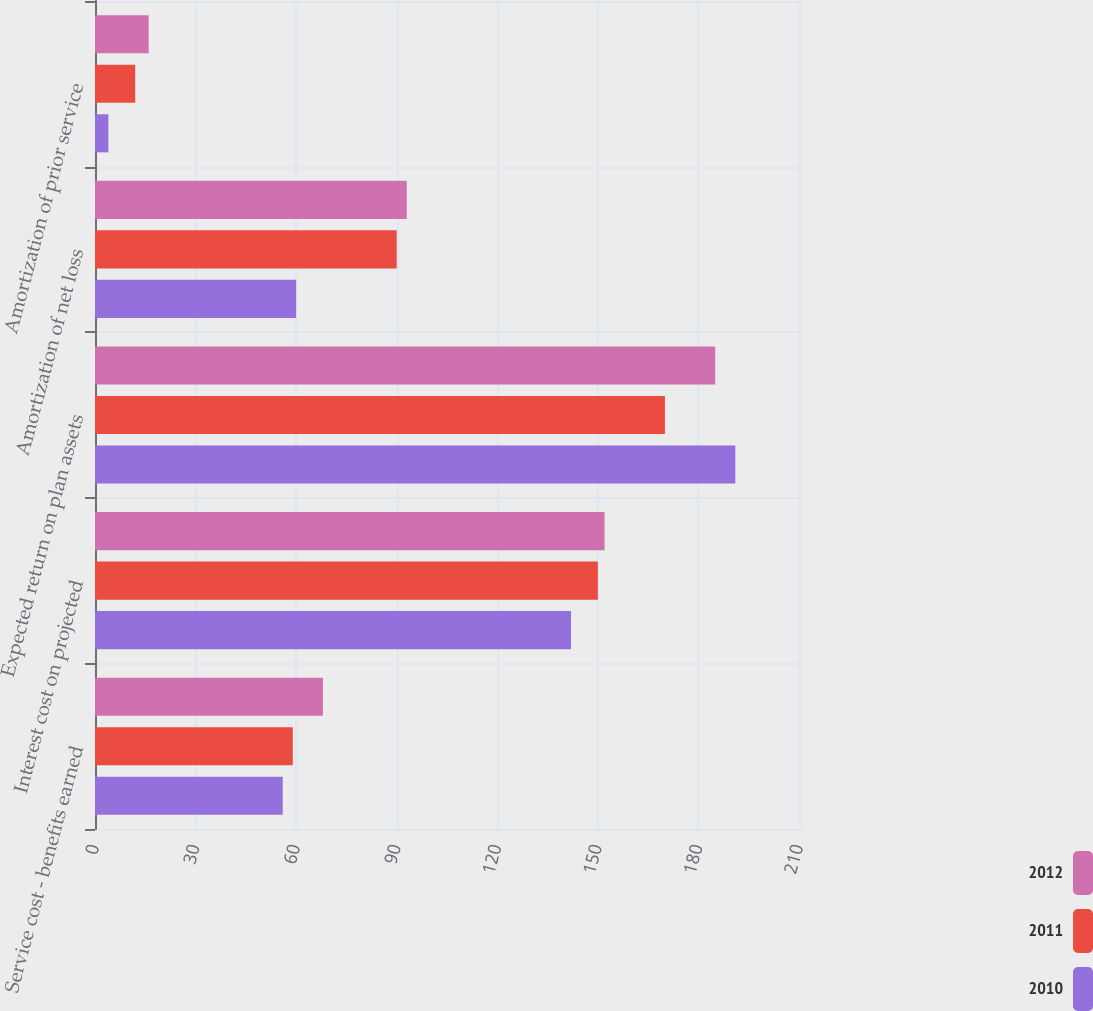Convert chart to OTSL. <chart><loc_0><loc_0><loc_500><loc_500><stacked_bar_chart><ecel><fcel>Service cost - benefits earned<fcel>Interest cost on projected<fcel>Expected return on plan assets<fcel>Amortization of net loss<fcel>Amortization of prior service<nl><fcel>2012<fcel>68<fcel>152<fcel>185<fcel>93<fcel>16<nl><fcel>2011<fcel>59<fcel>150<fcel>170<fcel>90<fcel>12<nl><fcel>2010<fcel>56<fcel>142<fcel>191<fcel>60<fcel>4<nl></chart> 